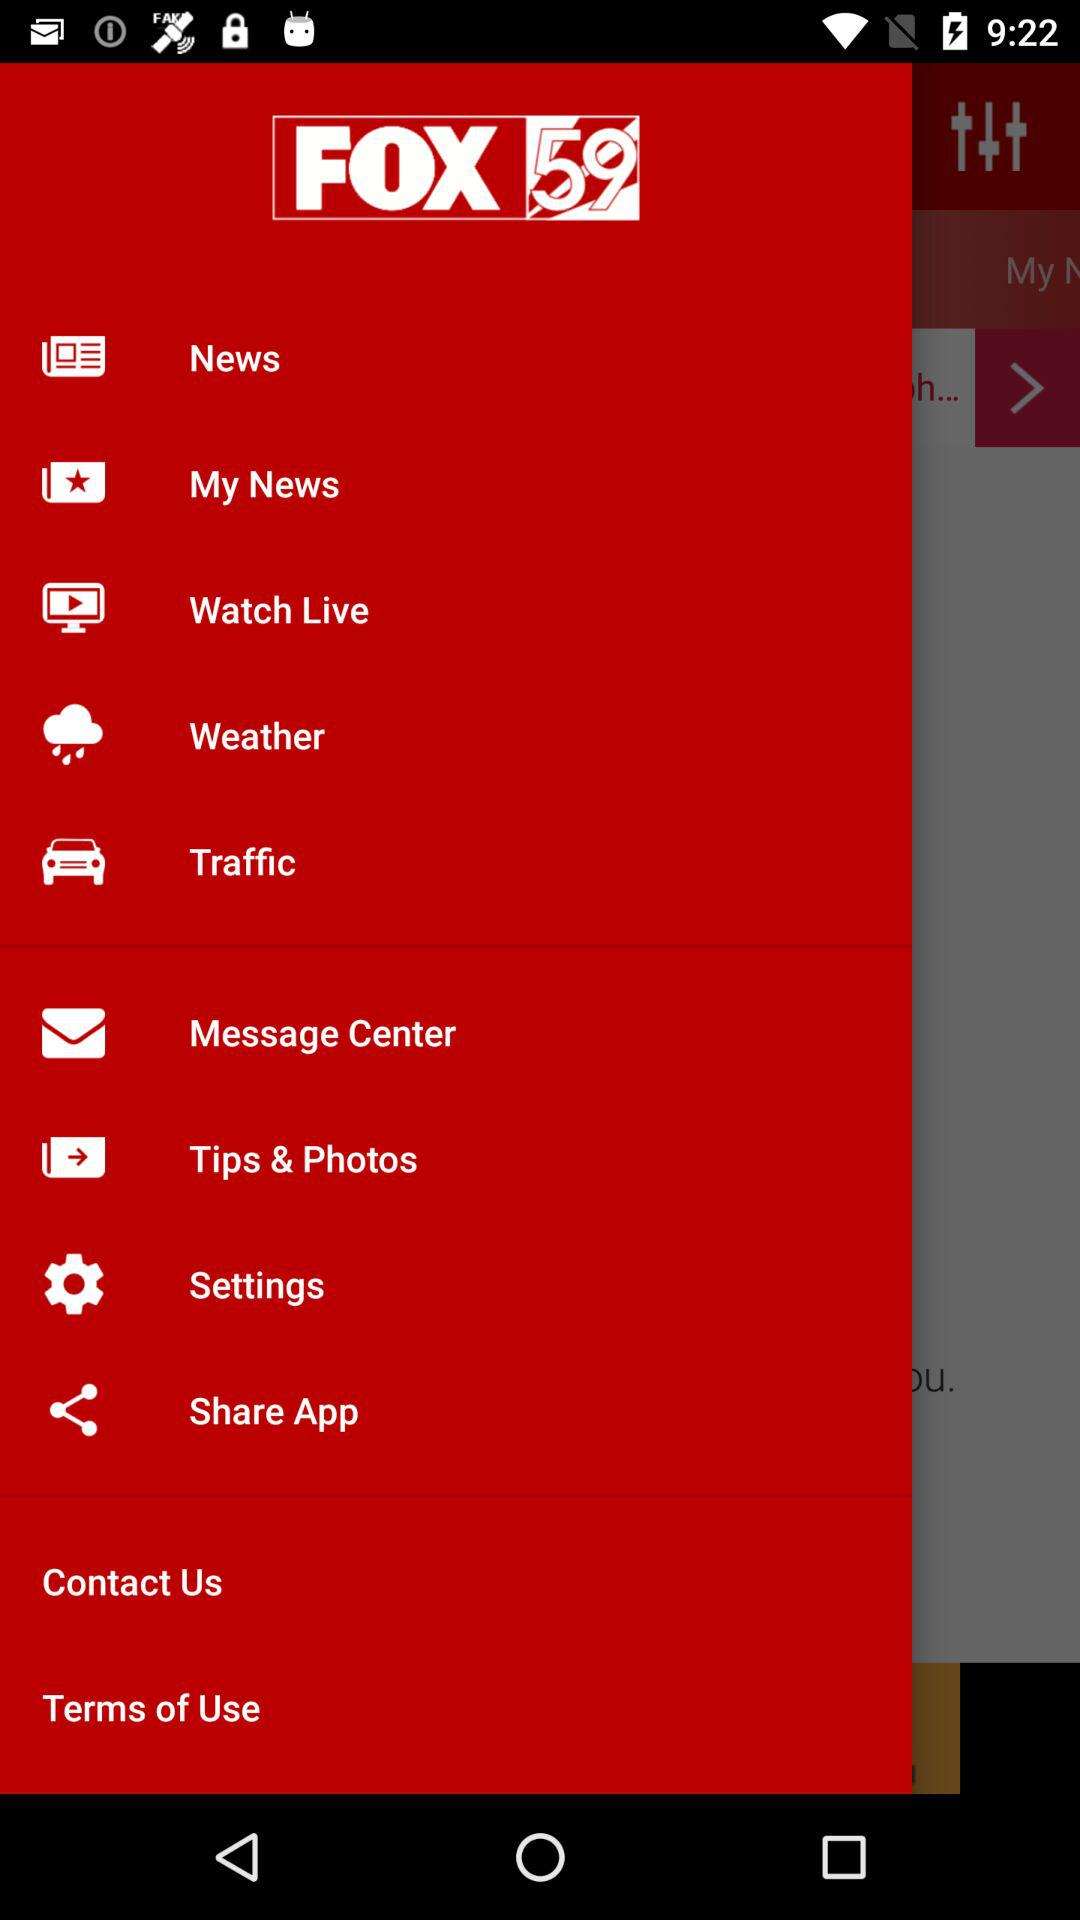What is the application name? The application name is "FOX 59". 